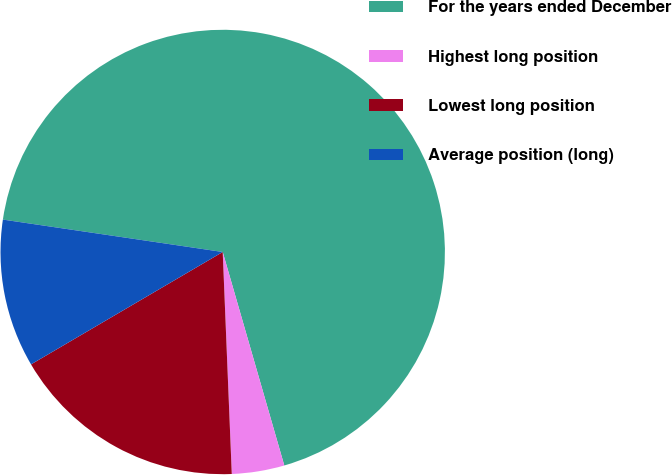Convert chart. <chart><loc_0><loc_0><loc_500><loc_500><pie_chart><fcel>For the years ended December<fcel>Highest long position<fcel>Lowest long position<fcel>Average position (long)<nl><fcel>68.2%<fcel>3.82%<fcel>17.21%<fcel>10.77%<nl></chart> 